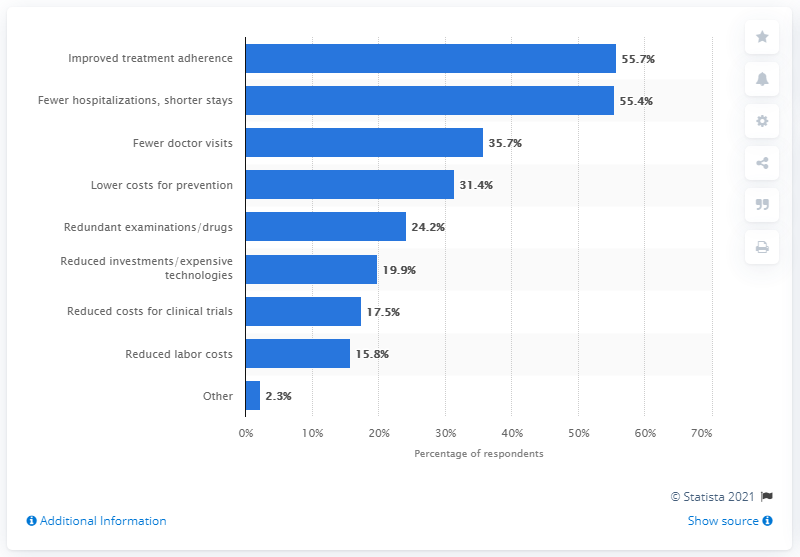Give some essential details in this illustration. 35.7% of respondents stated that fewer doctor visits could potentially result in cost savings. 